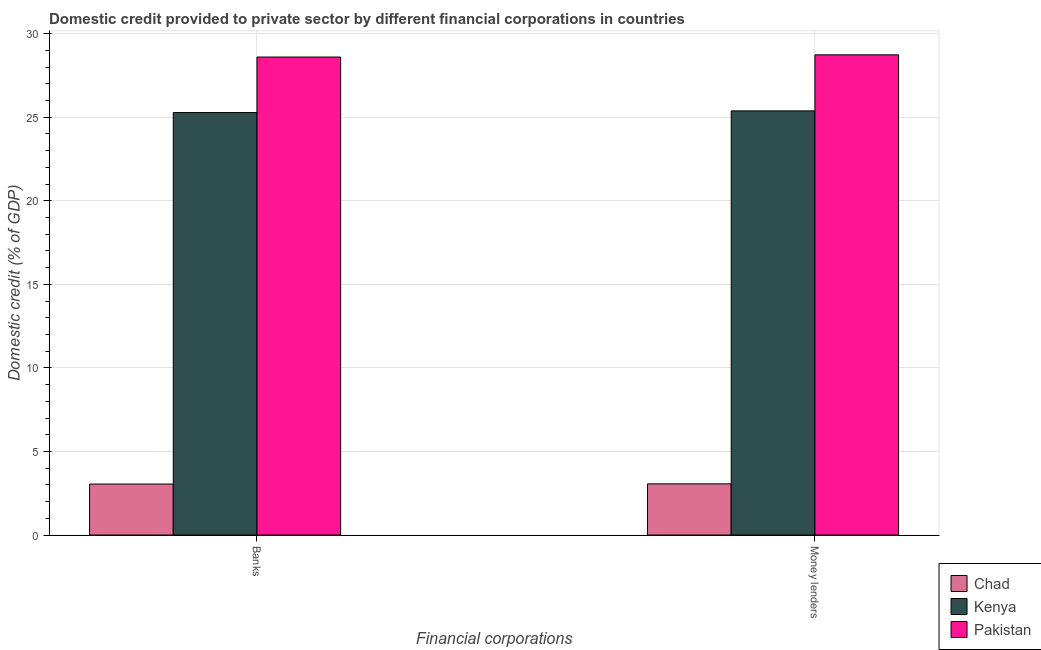Are the number of bars per tick equal to the number of legend labels?
Your answer should be compact. Yes. Are the number of bars on each tick of the X-axis equal?
Give a very brief answer. Yes. What is the label of the 2nd group of bars from the left?
Offer a terse response. Money lenders. What is the domestic credit provided by money lenders in Chad?
Offer a very short reply. 3.06. Across all countries, what is the maximum domestic credit provided by money lenders?
Provide a succinct answer. 28.73. Across all countries, what is the minimum domestic credit provided by banks?
Ensure brevity in your answer.  3.05. In which country was the domestic credit provided by money lenders maximum?
Provide a short and direct response. Pakistan. In which country was the domestic credit provided by money lenders minimum?
Ensure brevity in your answer.  Chad. What is the total domestic credit provided by banks in the graph?
Your response must be concise. 56.94. What is the difference between the domestic credit provided by money lenders in Pakistan and that in Chad?
Your response must be concise. 25.67. What is the difference between the domestic credit provided by banks in Chad and the domestic credit provided by money lenders in Kenya?
Ensure brevity in your answer.  -22.33. What is the average domestic credit provided by money lenders per country?
Your response must be concise. 19.06. What is the difference between the domestic credit provided by banks and domestic credit provided by money lenders in Pakistan?
Your answer should be compact. -0.13. In how many countries, is the domestic credit provided by money lenders greater than 19 %?
Offer a terse response. 2. What is the ratio of the domestic credit provided by banks in Chad to that in Pakistan?
Provide a succinct answer. 0.11. What does the 3rd bar from the left in Banks represents?
Offer a terse response. Pakistan. What does the 2nd bar from the right in Banks represents?
Provide a short and direct response. Kenya. How many bars are there?
Make the answer very short. 6. How many countries are there in the graph?
Your response must be concise. 3. Are the values on the major ticks of Y-axis written in scientific E-notation?
Give a very brief answer. No. How many legend labels are there?
Keep it short and to the point. 3. How are the legend labels stacked?
Offer a terse response. Vertical. What is the title of the graph?
Make the answer very short. Domestic credit provided to private sector by different financial corporations in countries. Does "Middle East & North Africa (all income levels)" appear as one of the legend labels in the graph?
Provide a short and direct response. No. What is the label or title of the X-axis?
Your response must be concise. Financial corporations. What is the label or title of the Y-axis?
Offer a very short reply. Domestic credit (% of GDP). What is the Domestic credit (% of GDP) of Chad in Banks?
Give a very brief answer. 3.05. What is the Domestic credit (% of GDP) of Kenya in Banks?
Ensure brevity in your answer.  25.28. What is the Domestic credit (% of GDP) in Pakistan in Banks?
Your answer should be very brief. 28.6. What is the Domestic credit (% of GDP) in Chad in Money lenders?
Provide a succinct answer. 3.06. What is the Domestic credit (% of GDP) in Kenya in Money lenders?
Provide a short and direct response. 25.38. What is the Domestic credit (% of GDP) in Pakistan in Money lenders?
Provide a succinct answer. 28.73. Across all Financial corporations, what is the maximum Domestic credit (% of GDP) in Chad?
Keep it short and to the point. 3.06. Across all Financial corporations, what is the maximum Domestic credit (% of GDP) in Kenya?
Your answer should be very brief. 25.38. Across all Financial corporations, what is the maximum Domestic credit (% of GDP) of Pakistan?
Your answer should be compact. 28.73. Across all Financial corporations, what is the minimum Domestic credit (% of GDP) of Chad?
Make the answer very short. 3.05. Across all Financial corporations, what is the minimum Domestic credit (% of GDP) of Kenya?
Your response must be concise. 25.28. Across all Financial corporations, what is the minimum Domestic credit (% of GDP) of Pakistan?
Provide a short and direct response. 28.6. What is the total Domestic credit (% of GDP) in Chad in the graph?
Offer a very short reply. 6.11. What is the total Domestic credit (% of GDP) of Kenya in the graph?
Give a very brief answer. 50.66. What is the total Domestic credit (% of GDP) of Pakistan in the graph?
Give a very brief answer. 57.34. What is the difference between the Domestic credit (% of GDP) of Chad in Banks and that in Money lenders?
Keep it short and to the point. -0.01. What is the difference between the Domestic credit (% of GDP) in Kenya in Banks and that in Money lenders?
Keep it short and to the point. -0.1. What is the difference between the Domestic credit (% of GDP) of Pakistan in Banks and that in Money lenders?
Provide a succinct answer. -0.13. What is the difference between the Domestic credit (% of GDP) of Chad in Banks and the Domestic credit (% of GDP) of Kenya in Money lenders?
Ensure brevity in your answer.  -22.33. What is the difference between the Domestic credit (% of GDP) of Chad in Banks and the Domestic credit (% of GDP) of Pakistan in Money lenders?
Provide a succinct answer. -25.68. What is the difference between the Domestic credit (% of GDP) in Kenya in Banks and the Domestic credit (% of GDP) in Pakistan in Money lenders?
Keep it short and to the point. -3.45. What is the average Domestic credit (% of GDP) of Chad per Financial corporations?
Your answer should be compact. 3.06. What is the average Domestic credit (% of GDP) of Kenya per Financial corporations?
Provide a succinct answer. 25.33. What is the average Domestic credit (% of GDP) in Pakistan per Financial corporations?
Your answer should be very brief. 28.67. What is the difference between the Domestic credit (% of GDP) in Chad and Domestic credit (% of GDP) in Kenya in Banks?
Ensure brevity in your answer.  -22.23. What is the difference between the Domestic credit (% of GDP) in Chad and Domestic credit (% of GDP) in Pakistan in Banks?
Make the answer very short. -25.55. What is the difference between the Domestic credit (% of GDP) in Kenya and Domestic credit (% of GDP) in Pakistan in Banks?
Offer a terse response. -3.32. What is the difference between the Domestic credit (% of GDP) in Chad and Domestic credit (% of GDP) in Kenya in Money lenders?
Keep it short and to the point. -22.32. What is the difference between the Domestic credit (% of GDP) of Chad and Domestic credit (% of GDP) of Pakistan in Money lenders?
Make the answer very short. -25.67. What is the difference between the Domestic credit (% of GDP) of Kenya and Domestic credit (% of GDP) of Pakistan in Money lenders?
Make the answer very short. -3.35. What is the ratio of the Domestic credit (% of GDP) in Chad in Banks to that in Money lenders?
Keep it short and to the point. 1. What is the ratio of the Domestic credit (% of GDP) in Kenya in Banks to that in Money lenders?
Provide a succinct answer. 1. What is the ratio of the Domestic credit (% of GDP) of Pakistan in Banks to that in Money lenders?
Offer a very short reply. 1. What is the difference between the highest and the second highest Domestic credit (% of GDP) of Chad?
Your answer should be very brief. 0.01. What is the difference between the highest and the second highest Domestic credit (% of GDP) in Kenya?
Keep it short and to the point. 0.1. What is the difference between the highest and the second highest Domestic credit (% of GDP) in Pakistan?
Ensure brevity in your answer.  0.13. What is the difference between the highest and the lowest Domestic credit (% of GDP) in Chad?
Give a very brief answer. 0.01. What is the difference between the highest and the lowest Domestic credit (% of GDP) in Kenya?
Your answer should be very brief. 0.1. What is the difference between the highest and the lowest Domestic credit (% of GDP) in Pakistan?
Keep it short and to the point. 0.13. 